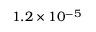Convert formula to latex. <formula><loc_0><loc_0><loc_500><loc_500>1 . 2 \times 1 0 ^ { - 5 }</formula> 